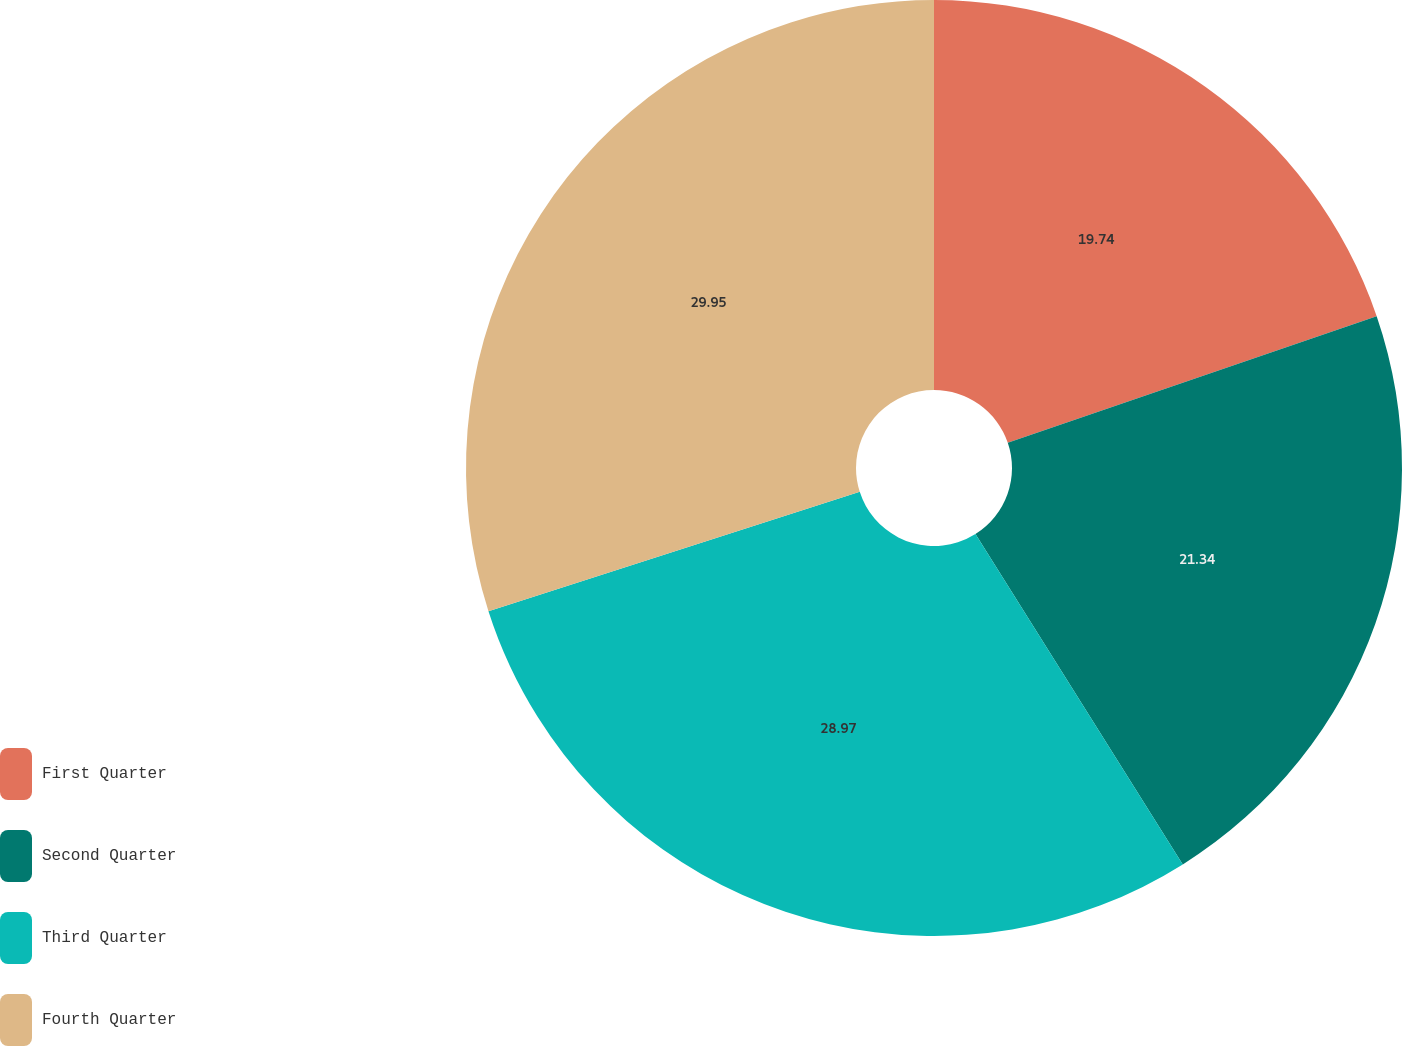<chart> <loc_0><loc_0><loc_500><loc_500><pie_chart><fcel>First Quarter<fcel>Second Quarter<fcel>Third Quarter<fcel>Fourth Quarter<nl><fcel>19.74%<fcel>21.34%<fcel>28.97%<fcel>29.95%<nl></chart> 